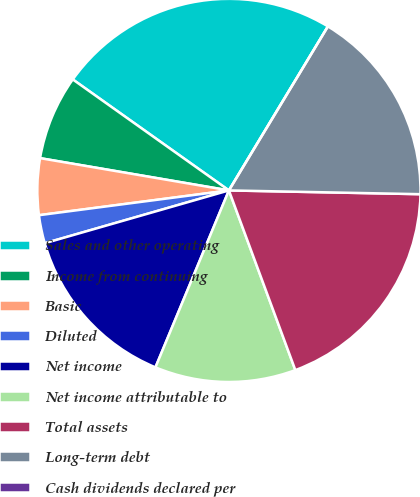<chart> <loc_0><loc_0><loc_500><loc_500><pie_chart><fcel>Sales and other operating<fcel>Income from continuing<fcel>Basic<fcel>Diluted<fcel>Net income<fcel>Net income attributable to<fcel>Total assets<fcel>Long-term debt<fcel>Cash dividends declared per<nl><fcel>23.81%<fcel>7.14%<fcel>4.76%<fcel>2.38%<fcel>14.29%<fcel>11.9%<fcel>19.05%<fcel>16.67%<fcel>0.0%<nl></chart> 